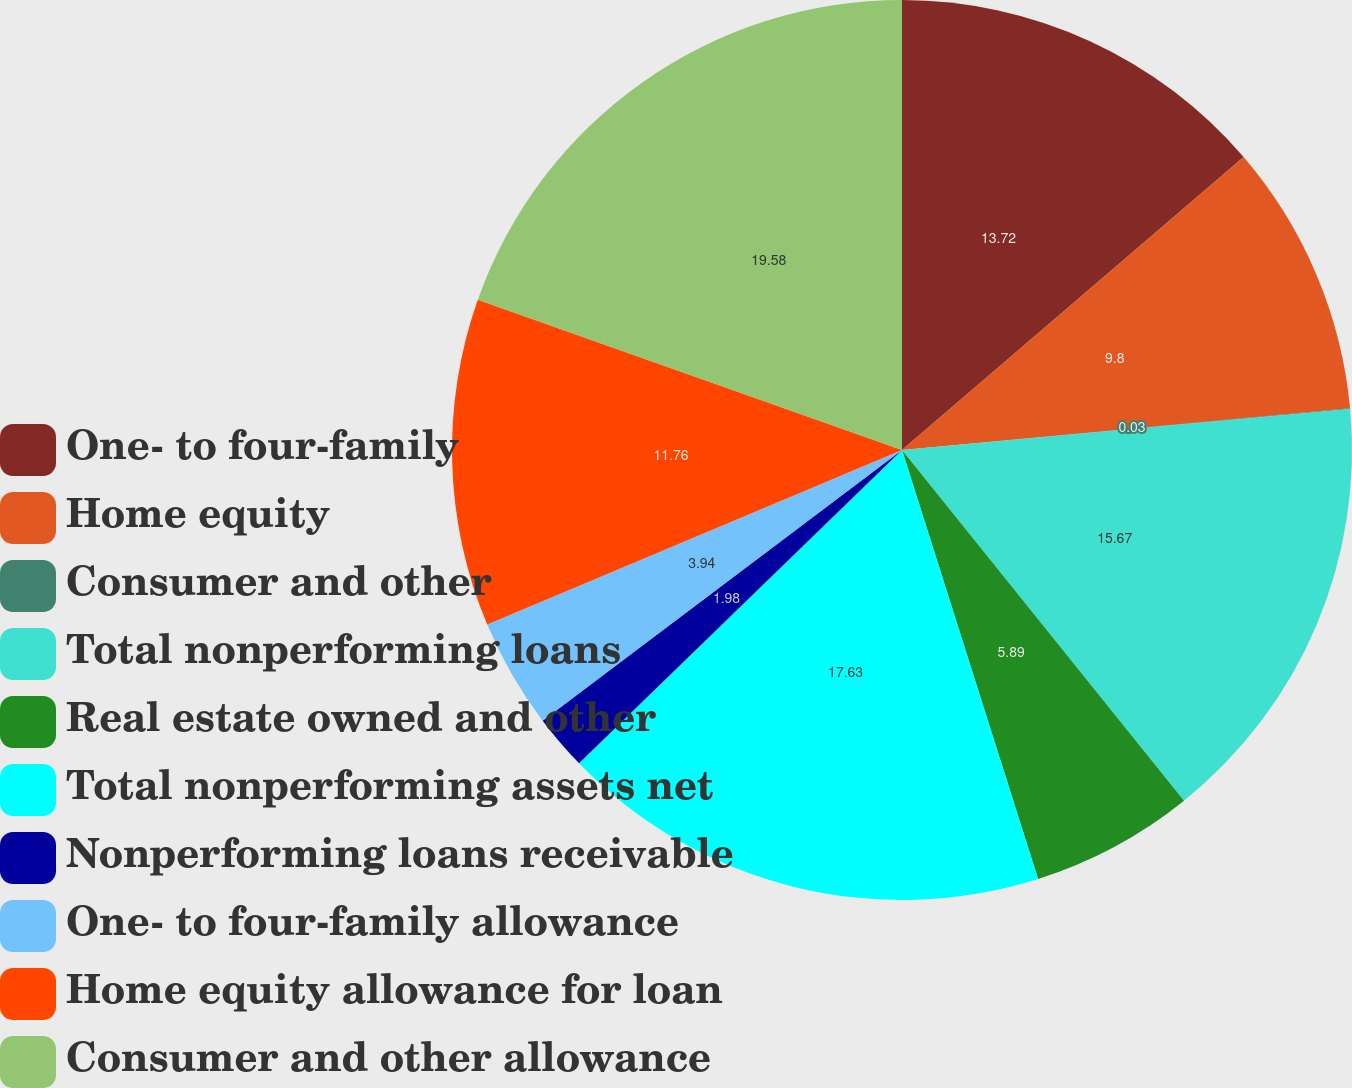Convert chart. <chart><loc_0><loc_0><loc_500><loc_500><pie_chart><fcel>One- to four-family<fcel>Home equity<fcel>Consumer and other<fcel>Total nonperforming loans<fcel>Real estate owned and other<fcel>Total nonperforming assets net<fcel>Nonperforming loans receivable<fcel>One- to four-family allowance<fcel>Home equity allowance for loan<fcel>Consumer and other allowance<nl><fcel>13.72%<fcel>9.8%<fcel>0.03%<fcel>15.67%<fcel>5.89%<fcel>17.63%<fcel>1.98%<fcel>3.94%<fcel>11.76%<fcel>19.58%<nl></chart> 